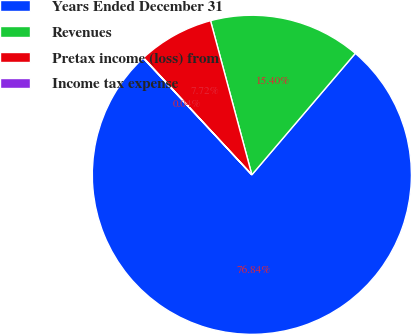Convert chart to OTSL. <chart><loc_0><loc_0><loc_500><loc_500><pie_chart><fcel>Years Ended December 31<fcel>Revenues<fcel>Pretax income (loss) from<fcel>Income tax expense<nl><fcel>76.84%<fcel>15.4%<fcel>7.72%<fcel>0.04%<nl></chart> 